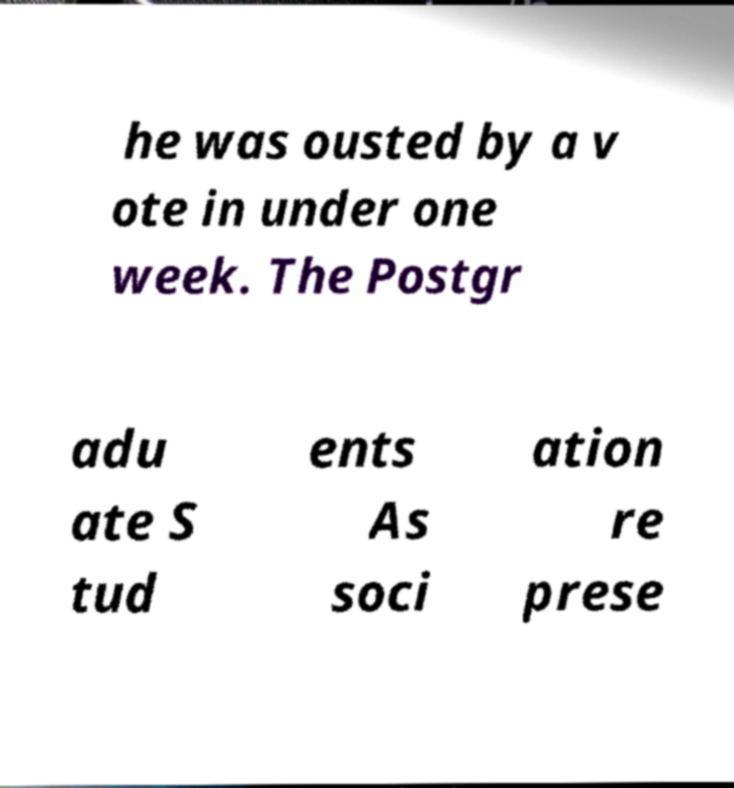I need the written content from this picture converted into text. Can you do that? he was ousted by a v ote in under one week. The Postgr adu ate S tud ents As soci ation re prese 